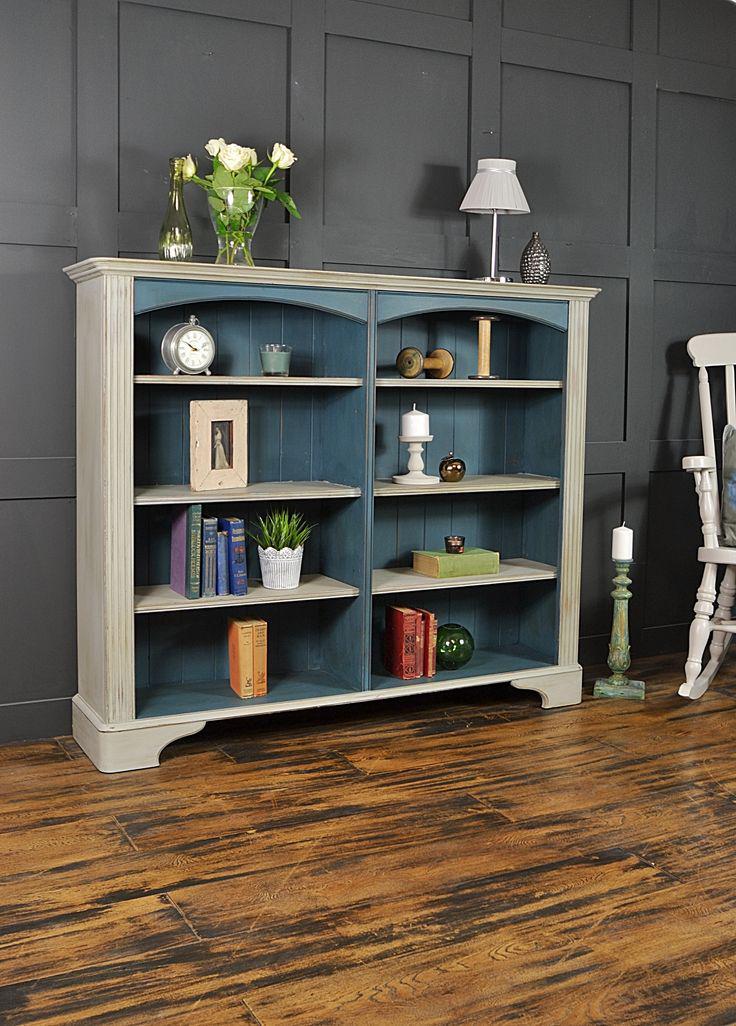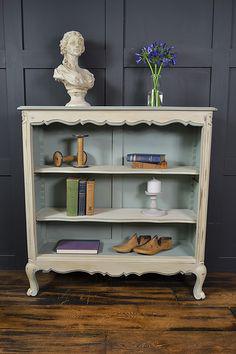The first image is the image on the left, the second image is the image on the right. Examine the images to the left and right. Is the description "there is a bookshelf on a wood floor and a vase of flowers on top" accurate? Answer yes or no. Yes. The first image is the image on the left, the second image is the image on the right. Evaluate the accuracy of this statement regarding the images: "In one image a bookshelf with four levels has a decorative inner arc framing the upper shelf on which a clock is sitting.". Is it true? Answer yes or no. Yes. 